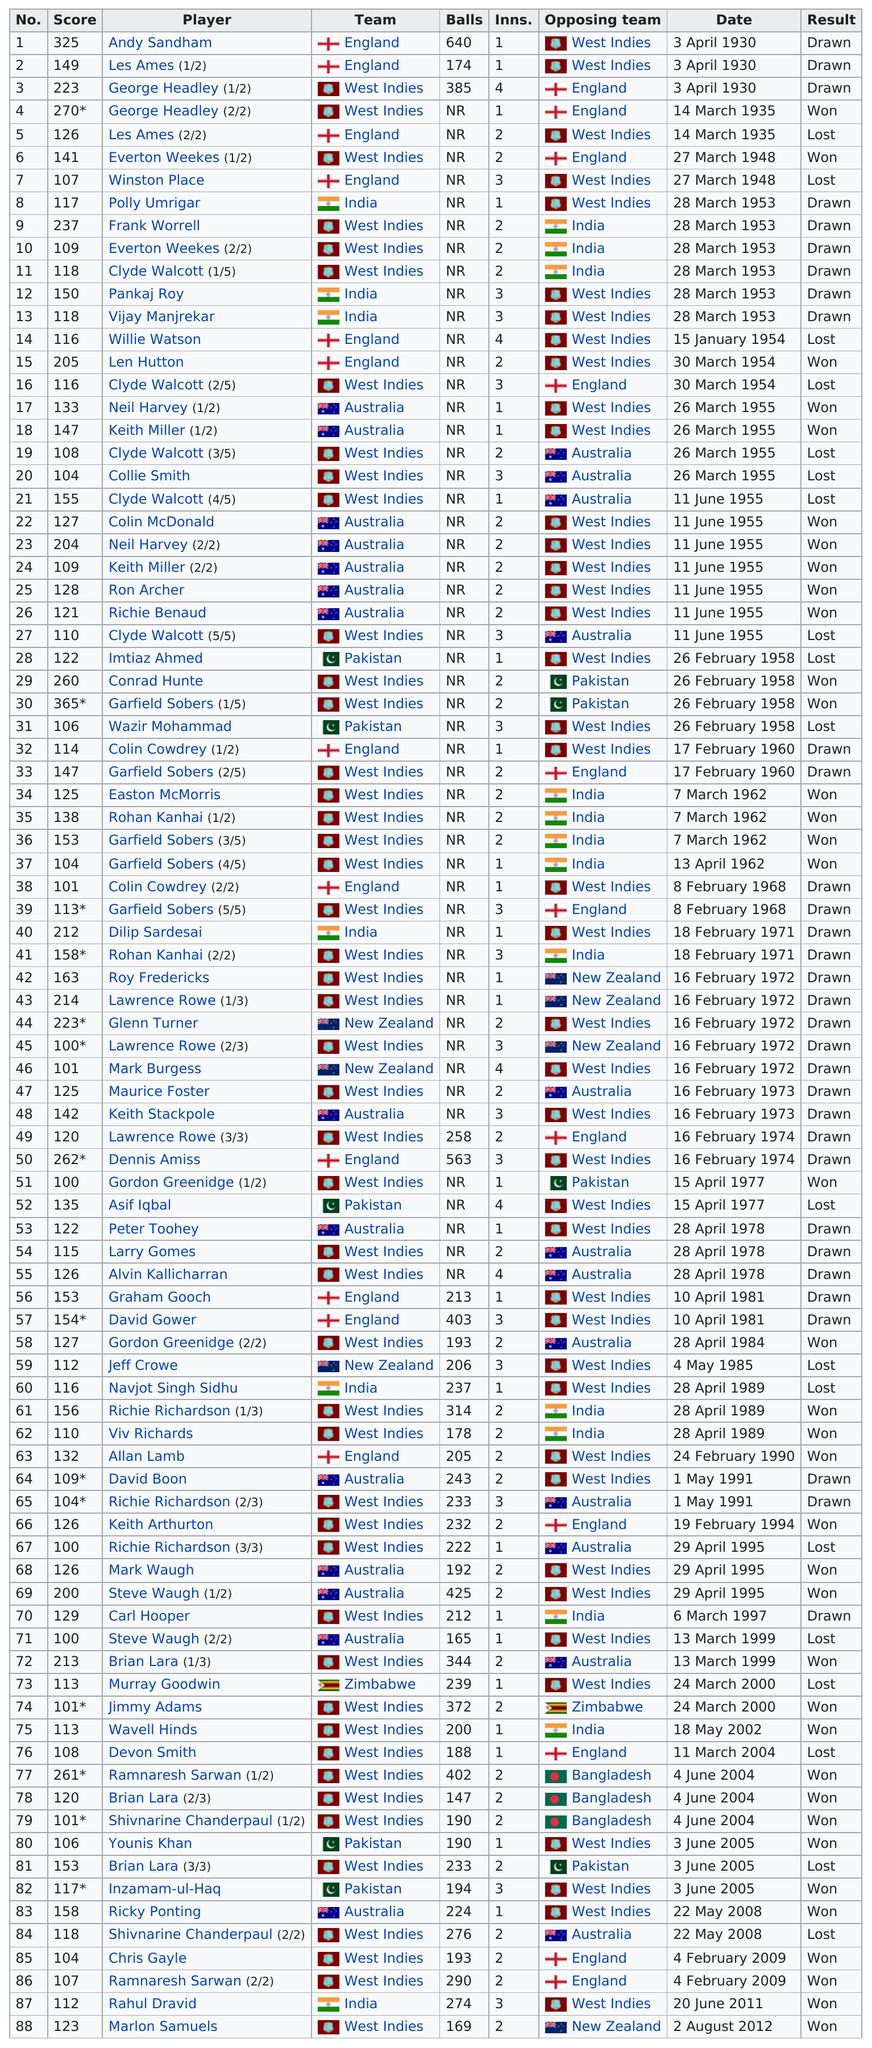Give some essential details in this illustration. The last player on this chart is Marlon Samuels. The West Indies have been listed the most under the opposing team column. The number of balls in listing number 3 was 385. Andy Sandham is listed first in the table. The dates in the list are presented in a consecutive order: YES. 